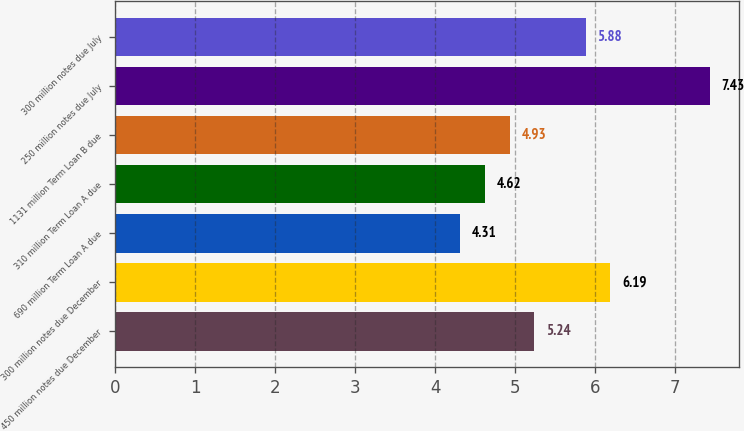<chart> <loc_0><loc_0><loc_500><loc_500><bar_chart><fcel>450 million notes due December<fcel>300 million notes due December<fcel>690 million Term Loan A due<fcel>310 million Term Loan A due<fcel>1131 million Term Loan B due<fcel>250 million notes due July<fcel>300 million notes due July<nl><fcel>5.24<fcel>6.19<fcel>4.31<fcel>4.62<fcel>4.93<fcel>7.43<fcel>5.88<nl></chart> 